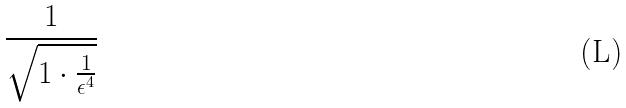<formula> <loc_0><loc_0><loc_500><loc_500>\frac { 1 } { \sqrt { 1 \cdot \frac { 1 } { \epsilon ^ { 4 } } } }</formula> 